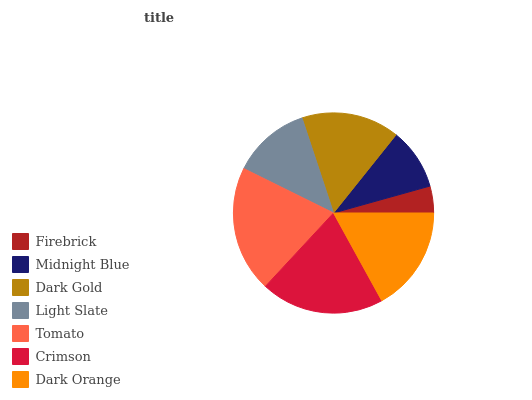Is Firebrick the minimum?
Answer yes or no. Yes. Is Tomato the maximum?
Answer yes or no. Yes. Is Midnight Blue the minimum?
Answer yes or no. No. Is Midnight Blue the maximum?
Answer yes or no. No. Is Midnight Blue greater than Firebrick?
Answer yes or no. Yes. Is Firebrick less than Midnight Blue?
Answer yes or no. Yes. Is Firebrick greater than Midnight Blue?
Answer yes or no. No. Is Midnight Blue less than Firebrick?
Answer yes or no. No. Is Dark Gold the high median?
Answer yes or no. Yes. Is Dark Gold the low median?
Answer yes or no. Yes. Is Midnight Blue the high median?
Answer yes or no. No. Is Crimson the low median?
Answer yes or no. No. 